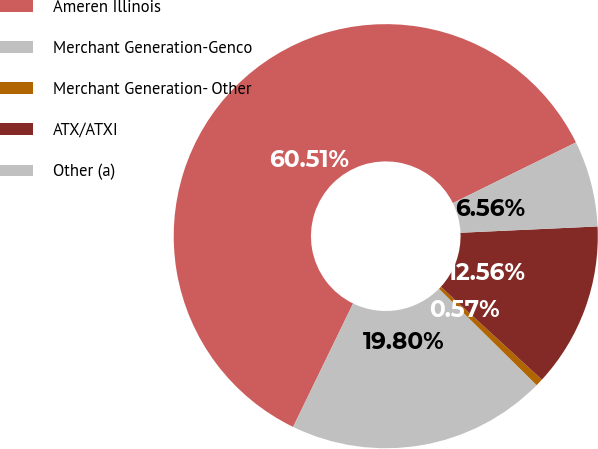<chart> <loc_0><loc_0><loc_500><loc_500><pie_chart><fcel>Ameren Illinois<fcel>Merchant Generation-Genco<fcel>Merchant Generation- Other<fcel>ATX/ATXI<fcel>Other (a)<nl><fcel>60.52%<fcel>19.8%<fcel>0.57%<fcel>12.56%<fcel>6.56%<nl></chart> 